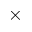<formula> <loc_0><loc_0><loc_500><loc_500>\times</formula> 